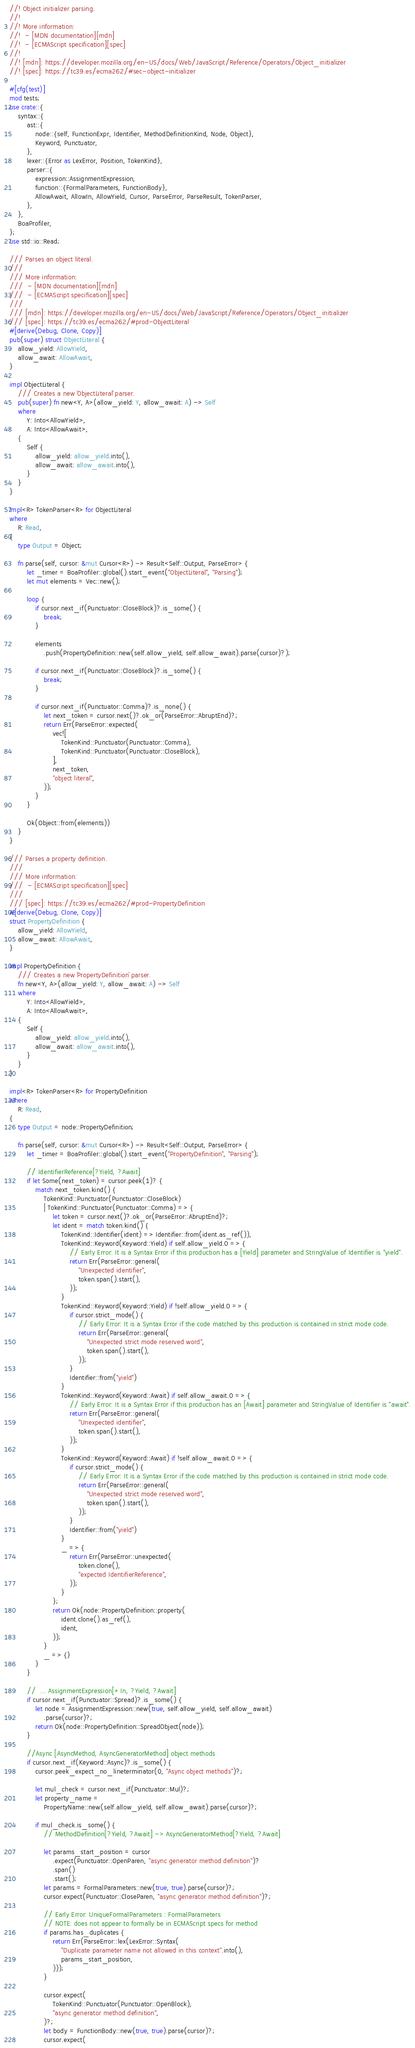<code> <loc_0><loc_0><loc_500><loc_500><_Rust_>//! Object initializer parsing.
//!
//! More information:
//!  - [MDN documentation][mdn]
//!  - [ECMAScript specification][spec]
//!
//! [mdn]: https://developer.mozilla.org/en-US/docs/Web/JavaScript/Reference/Operators/Object_initializer
//! [spec]: https://tc39.es/ecma262/#sec-object-initializer

#[cfg(test)]
mod tests;
use crate::{
    syntax::{
        ast::{
            node::{self, FunctionExpr, Identifier, MethodDefinitionKind, Node, Object},
            Keyword, Punctuator,
        },
        lexer::{Error as LexError, Position, TokenKind},
        parser::{
            expression::AssignmentExpression,
            function::{FormalParameters, FunctionBody},
            AllowAwait, AllowIn, AllowYield, Cursor, ParseError, ParseResult, TokenParser,
        },
    },
    BoaProfiler,
};
use std::io::Read;

/// Parses an object literal.
///
/// More information:
///  - [MDN documentation][mdn]
///  - [ECMAScript specification][spec]
///
/// [mdn]: https://developer.mozilla.org/en-US/docs/Web/JavaScript/Reference/Operators/Object_initializer
/// [spec]: https://tc39.es/ecma262/#prod-ObjectLiteral
#[derive(Debug, Clone, Copy)]
pub(super) struct ObjectLiteral {
    allow_yield: AllowYield,
    allow_await: AllowAwait,
}

impl ObjectLiteral {
    /// Creates a new `ObjectLiteral` parser.
    pub(super) fn new<Y, A>(allow_yield: Y, allow_await: A) -> Self
    where
        Y: Into<AllowYield>,
        A: Into<AllowAwait>,
    {
        Self {
            allow_yield: allow_yield.into(),
            allow_await: allow_await.into(),
        }
    }
}

impl<R> TokenParser<R> for ObjectLiteral
where
    R: Read,
{
    type Output = Object;

    fn parse(self, cursor: &mut Cursor<R>) -> Result<Self::Output, ParseError> {
        let _timer = BoaProfiler::global().start_event("ObjectLiteral", "Parsing");
        let mut elements = Vec::new();

        loop {
            if cursor.next_if(Punctuator::CloseBlock)?.is_some() {
                break;
            }

            elements
                .push(PropertyDefinition::new(self.allow_yield, self.allow_await).parse(cursor)?);

            if cursor.next_if(Punctuator::CloseBlock)?.is_some() {
                break;
            }

            if cursor.next_if(Punctuator::Comma)?.is_none() {
                let next_token = cursor.next()?.ok_or(ParseError::AbruptEnd)?;
                return Err(ParseError::expected(
                    vec![
                        TokenKind::Punctuator(Punctuator::Comma),
                        TokenKind::Punctuator(Punctuator::CloseBlock),
                    ],
                    next_token,
                    "object literal",
                ));
            }
        }

        Ok(Object::from(elements))
    }
}

/// Parses a property definition.
///
/// More information:
///  - [ECMAScript specification][spec]
///
/// [spec]: https://tc39.es/ecma262/#prod-PropertyDefinition
#[derive(Debug, Clone, Copy)]
struct PropertyDefinition {
    allow_yield: AllowYield,
    allow_await: AllowAwait,
}

impl PropertyDefinition {
    /// Creates a new `PropertyDefinition` parser.
    fn new<Y, A>(allow_yield: Y, allow_await: A) -> Self
    where
        Y: Into<AllowYield>,
        A: Into<AllowAwait>,
    {
        Self {
            allow_yield: allow_yield.into(),
            allow_await: allow_await.into(),
        }
    }
}

impl<R> TokenParser<R> for PropertyDefinition
where
    R: Read,
{
    type Output = node::PropertyDefinition;

    fn parse(self, cursor: &mut Cursor<R>) -> Result<Self::Output, ParseError> {
        let _timer = BoaProfiler::global().start_event("PropertyDefinition", "Parsing");

        // IdentifierReference[?Yield, ?Await]
        if let Some(next_token) = cursor.peek(1)? {
            match next_token.kind() {
                TokenKind::Punctuator(Punctuator::CloseBlock)
                | TokenKind::Punctuator(Punctuator::Comma) => {
                    let token = cursor.next()?.ok_or(ParseError::AbruptEnd)?;
                    let ident = match token.kind() {
                        TokenKind::Identifier(ident) => Identifier::from(ident.as_ref()),
                        TokenKind::Keyword(Keyword::Yield) if self.allow_yield.0 => {
                            // Early Error: It is a Syntax Error if this production has a [Yield] parameter and StringValue of Identifier is "yield".
                            return Err(ParseError::general(
                                "Unexpected identifier",
                                token.span().start(),
                            ));
                        }
                        TokenKind::Keyword(Keyword::Yield) if !self.allow_yield.0 => {
                            if cursor.strict_mode() {
                                // Early Error: It is a Syntax Error if the code matched by this production is contained in strict mode code.
                                return Err(ParseError::general(
                                    "Unexpected strict mode reserved word",
                                    token.span().start(),
                                ));
                            }
                            Identifier::from("yield")
                        }
                        TokenKind::Keyword(Keyword::Await) if self.allow_await.0 => {
                            // Early Error: It is a Syntax Error if this production has an [Await] parameter and StringValue of Identifier is "await".
                            return Err(ParseError::general(
                                "Unexpected identifier",
                                token.span().start(),
                            ));
                        }
                        TokenKind::Keyword(Keyword::Await) if !self.allow_await.0 => {
                            if cursor.strict_mode() {
                                // Early Error: It is a Syntax Error if the code matched by this production is contained in strict mode code.
                                return Err(ParseError::general(
                                    "Unexpected strict mode reserved word",
                                    token.span().start(),
                                ));
                            }
                            Identifier::from("yield")
                        }
                        _ => {
                            return Err(ParseError::unexpected(
                                token.clone(),
                                "expected IdentifierReference",
                            ));
                        }
                    };
                    return Ok(node::PropertyDefinition::property(
                        ident.clone().as_ref(),
                        ident,
                    ));
                }
                _ => {}
            }
        }

        //  ... AssignmentExpression[+In, ?Yield, ?Await]
        if cursor.next_if(Punctuator::Spread)?.is_some() {
            let node = AssignmentExpression::new(true, self.allow_yield, self.allow_await)
                .parse(cursor)?;
            return Ok(node::PropertyDefinition::SpreadObject(node));
        }

        //Async [AsyncMethod, AsyncGeneratorMethod] object methods
        if cursor.next_if(Keyword::Async)?.is_some() {
            cursor.peek_expect_no_lineterminator(0, "Async object methods")?;

            let mul_check = cursor.next_if(Punctuator::Mul)?;
            let property_name =
                PropertyName::new(self.allow_yield, self.allow_await).parse(cursor)?;

            if mul_check.is_some() {
                // MethodDefinition[?Yield, ?Await] -> AsyncGeneratorMethod[?Yield, ?Await]

                let params_start_position = cursor
                    .expect(Punctuator::OpenParen, "async generator method definition")?
                    .span()
                    .start();
                let params = FormalParameters::new(true, true).parse(cursor)?;
                cursor.expect(Punctuator::CloseParen, "async generator method definition")?;

                // Early Error: UniqueFormalParameters : FormalParameters
                // NOTE: does not appear to formally be in ECMAScript specs for method
                if params.has_duplicates {
                    return Err(ParseError::lex(LexError::Syntax(
                        "Duplicate parameter name not allowed in this context".into(),
                        params_start_position,
                    )));
                }

                cursor.expect(
                    TokenKind::Punctuator(Punctuator::OpenBlock),
                    "async generator method definition",
                )?;
                let body = FunctionBody::new(true, true).parse(cursor)?;
                cursor.expect(</code> 